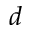<formula> <loc_0><loc_0><loc_500><loc_500>d</formula> 